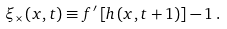<formula> <loc_0><loc_0><loc_500><loc_500>\xi _ { \times } \left ( { x , t } \right ) \equiv f ^ { \prime } \left [ { h \left ( { x , t + 1 } \right ) } \right ] - 1 \, .</formula> 